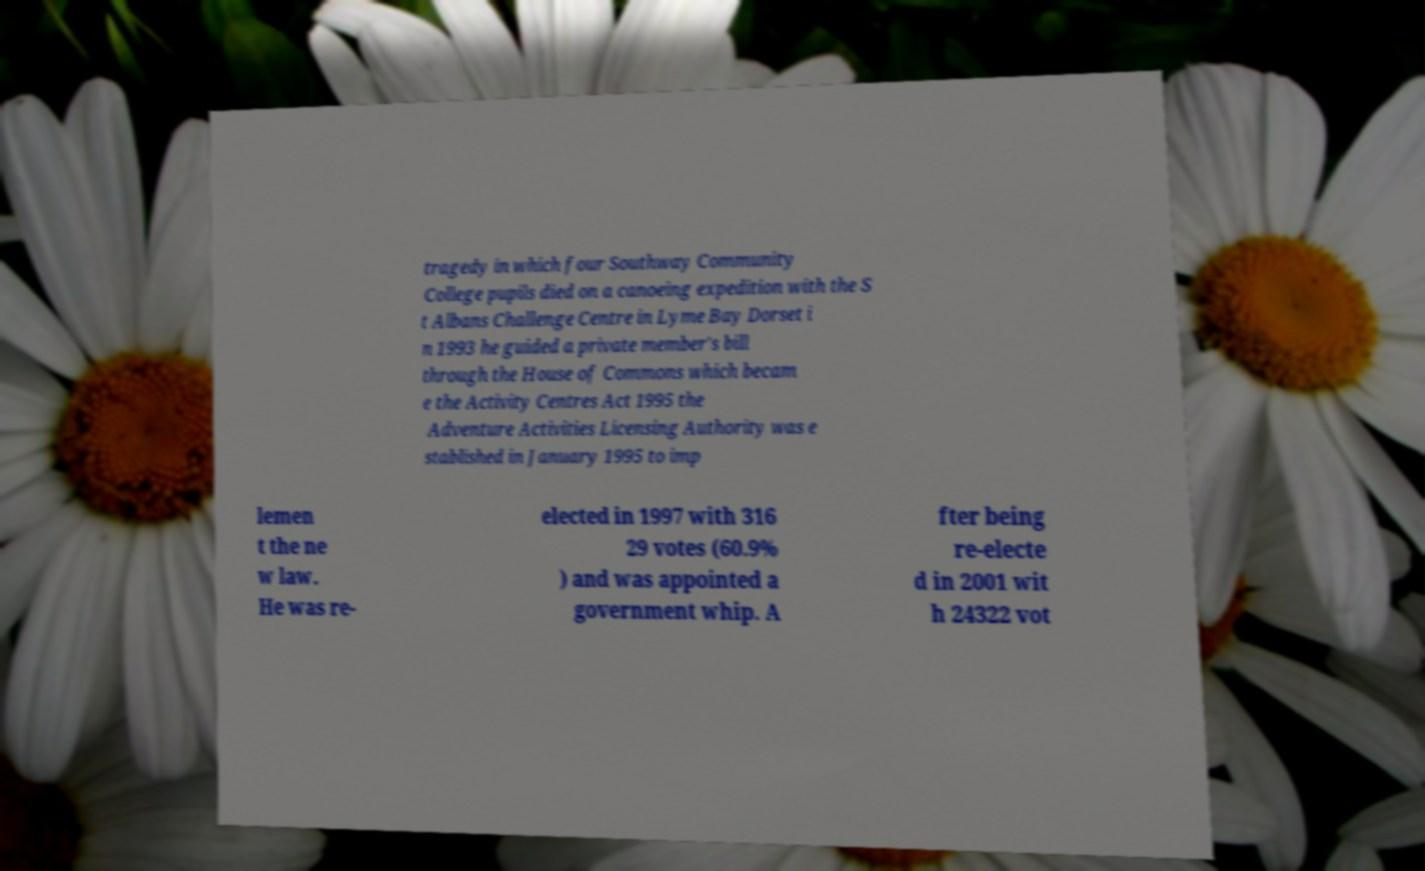Please read and relay the text visible in this image. What does it say? tragedy in which four Southway Community College pupils died on a canoeing expedition with the S t Albans Challenge Centre in Lyme Bay Dorset i n 1993 he guided a private member's bill through the House of Commons which becam e the Activity Centres Act 1995 the Adventure Activities Licensing Authority was e stablished in January 1995 to imp lemen t the ne w law. He was re- elected in 1997 with 316 29 votes (60.9% ) and was appointed a government whip. A fter being re-electe d in 2001 wit h 24322 vot 